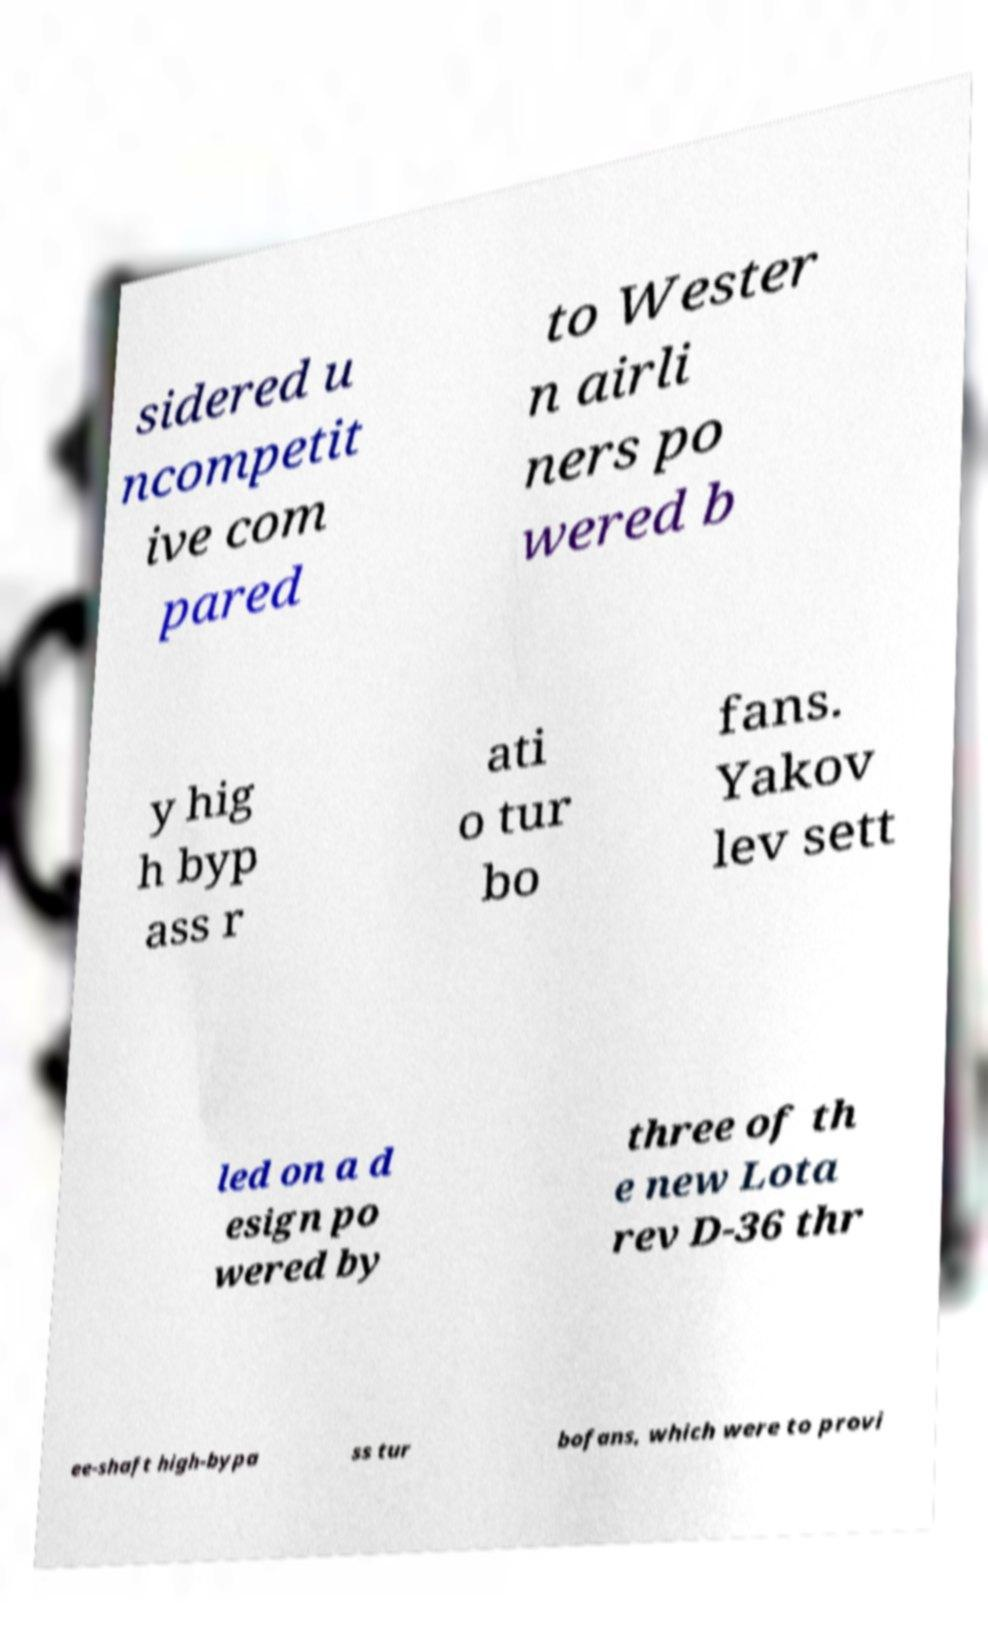I need the written content from this picture converted into text. Can you do that? sidered u ncompetit ive com pared to Wester n airli ners po wered b y hig h byp ass r ati o tur bo fans. Yakov lev sett led on a d esign po wered by three of th e new Lota rev D-36 thr ee-shaft high-bypa ss tur bofans, which were to provi 